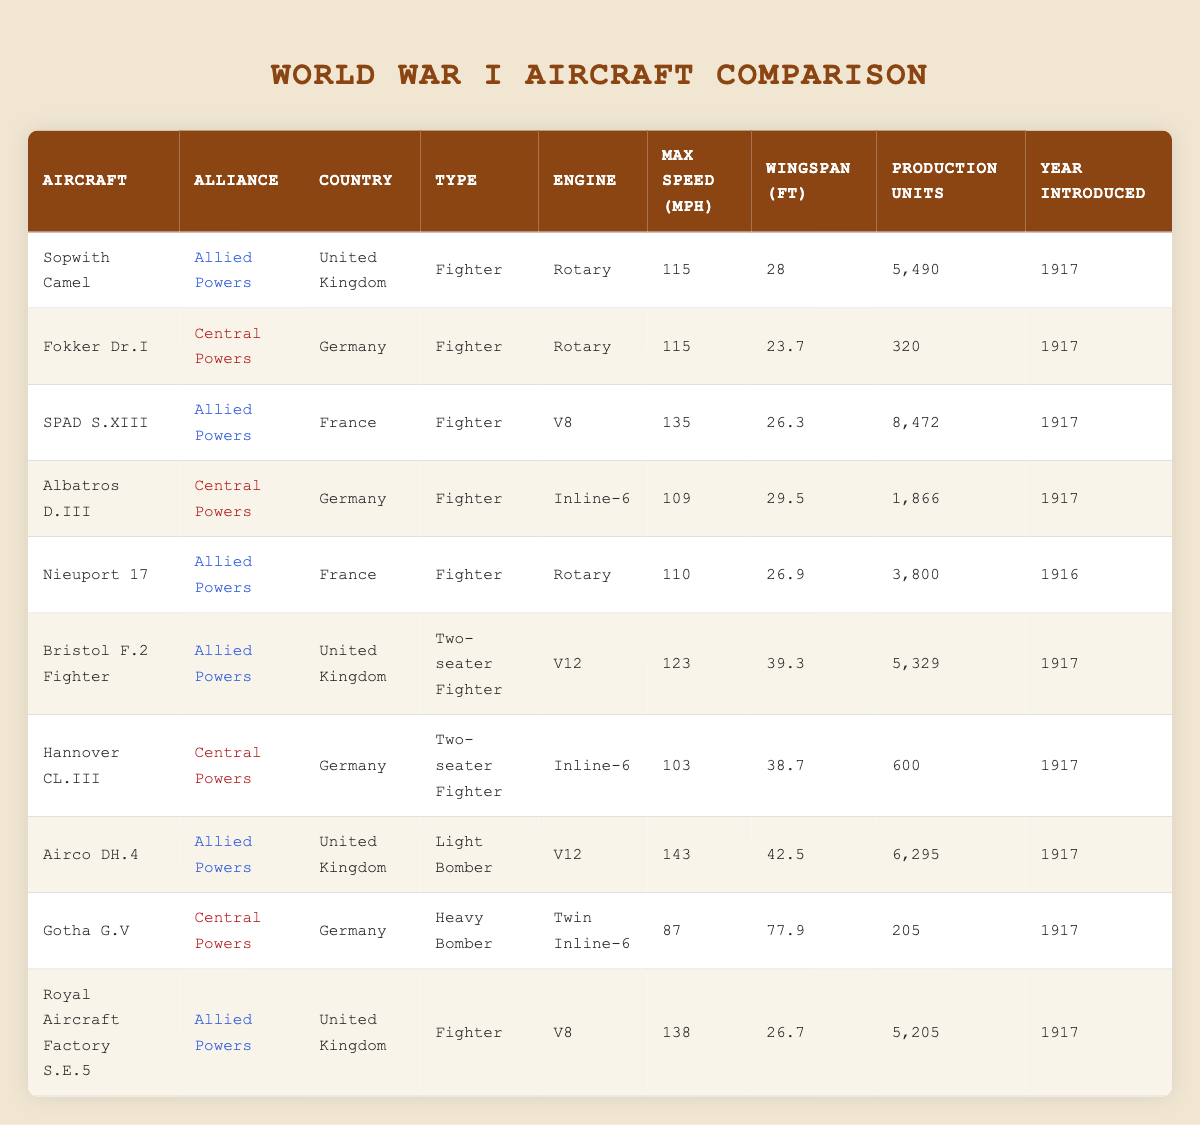What is the maximum speed of the Sopwith Camel? The maximum speed of the Sopwith Camel, as listed in the table, is 115 mph.
Answer: 115 mph How many production units were made for the SPAD S.XIII? According to the table, the SPAD S.XIII had 8,472 production units created.
Answer: 8,472 Which aircraft has the largest wingspan? By comparing the wingspan values, the Gotha G.V has the largest wingspan at 77.9 feet.
Answer: 77.9 feet True or False: The Royal Aircraft Factory S.E.5 has a higher maximum speed than the Albatros D.III. The maximum speed of the Royal Aircraft Factory S.E.5 is 138 mph, while Albatros D.III has 109 mph, making the statement true.
Answer: True What is the average production number of aircraft from the Central Powers? The production numbers for Central Powers are 320 (Fokker Dr.I), 1866 (Albatros D.III), 600 (Hannover CL.III), and 205 (Gotha G.V), which sums to 2991. Dividing by 4 gives an average of 747.75 units.
Answer: 747.75 Which type of aircraft was introduced first, the Nieuport 17 or the Sopwith Camel? The Nieuport 17 was introduced in 1916, while the Sopwith Camel was introduced in 1917, indicating that the Nieuport 17 was introduced first.
Answer: Nieuport 17 How many more production units were made of the SPAD S.XIII compared to the Fokker Dr.I? The SPAD S.XIII has 8,472 production units and the Fokker Dr.I has 320 units. The difference is 8,472 - 320 = 8,152 units.
Answer: 8,152 Can you name all the aircraft with a rotary engine? The aircraft with a rotary engine are the Sopwith Camel, Fokker Dr.I, Nieuport 17, and Airco DH.4.
Answer: Sopwith Camel, Fokker Dr.I, Nieuport 17, Airco DH.4 